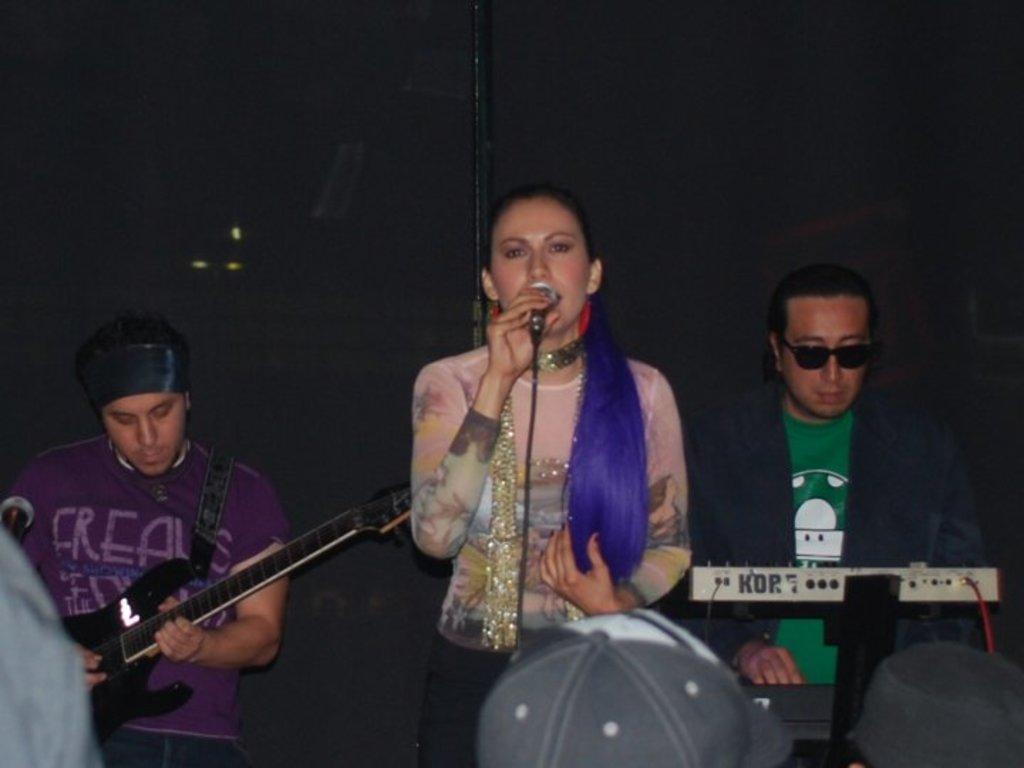In one or two sentences, can you explain what this image depicts? In the image we can see there are people who are holding guitar in their hand and mic and playing casio. 